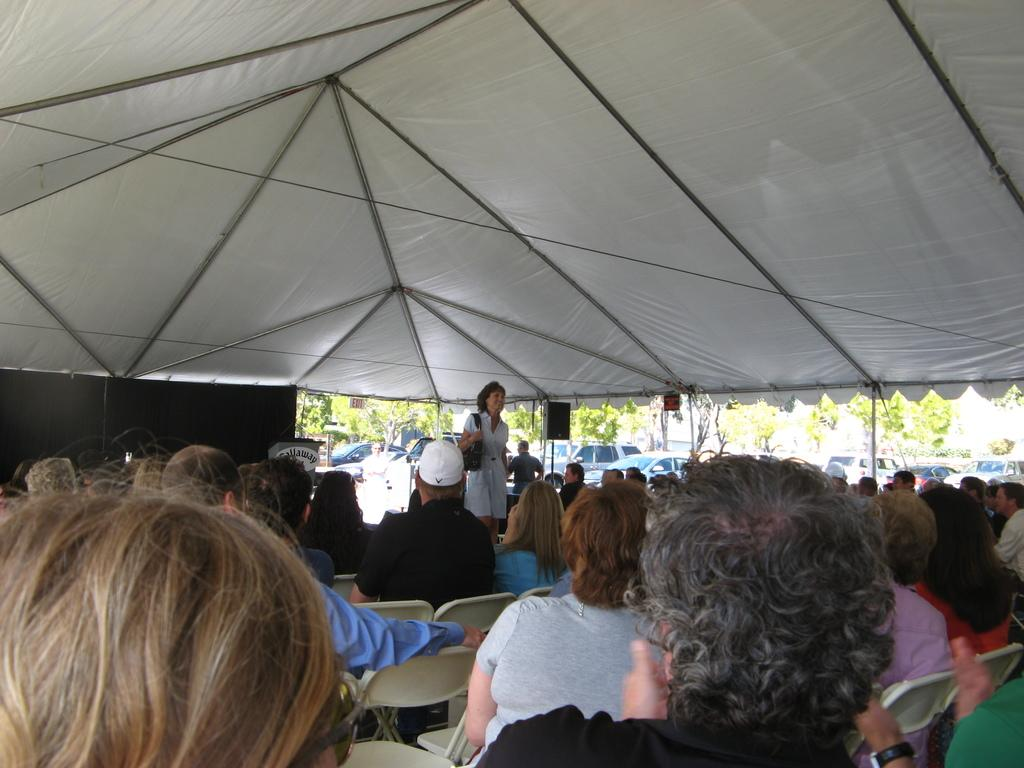What is happening in the image involving a group of people? There is a group of people in the image, and they are sitting on chairs. What can be seen in the background of the image? In the background of the image, there are cars and trees. What surprise did the people discover while sitting on the chairs in the image? There is no indication of a surprise or discovery in the image; the people are simply sitting on chairs. 